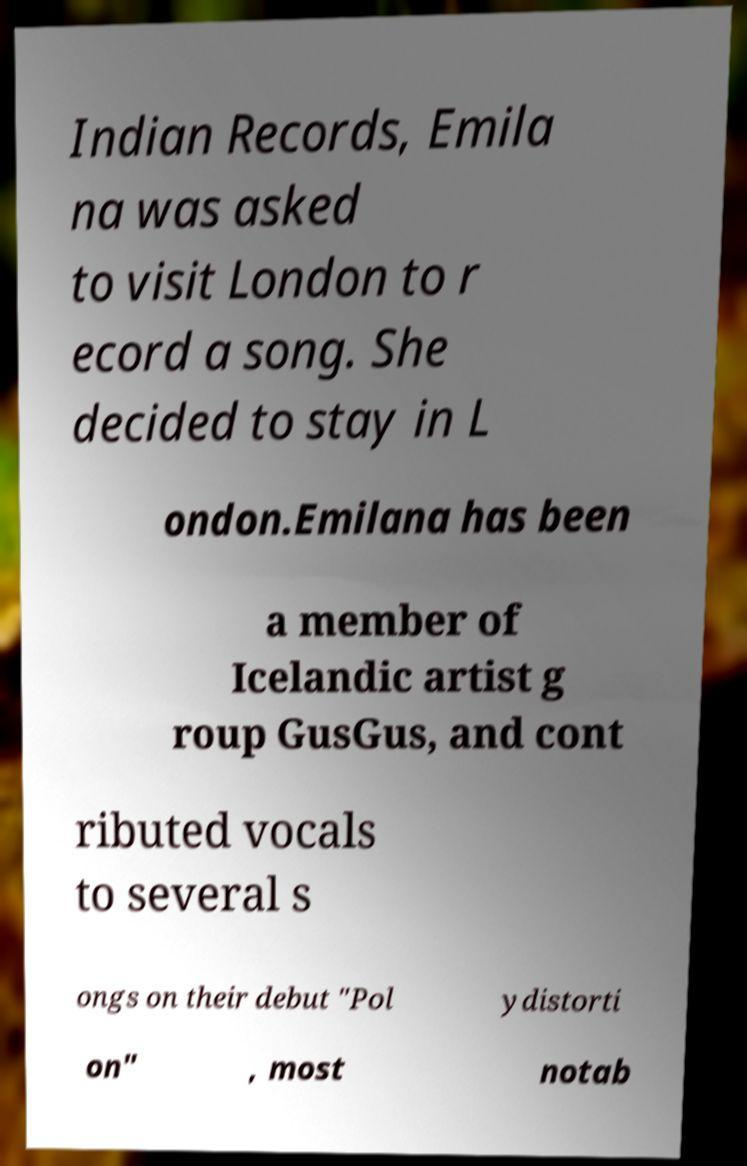Please identify and transcribe the text found in this image. Indian Records, Emila na was asked to visit London to r ecord a song. She decided to stay in L ondon.Emilana has been a member of Icelandic artist g roup GusGus, and cont ributed vocals to several s ongs on their debut "Pol ydistorti on" , most notab 